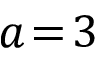Convert formula to latex. <formula><loc_0><loc_0><loc_500><loc_500>a \, = \, 3</formula> 